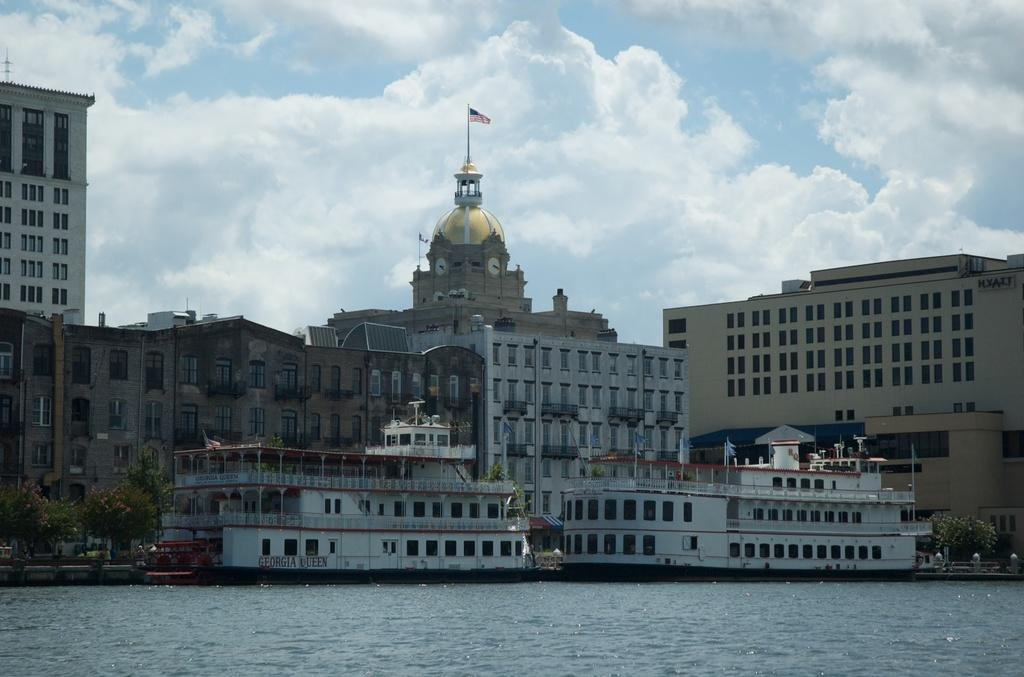What is on the water in the image? There are ships on the water in the image. What else can be seen in the image besides the ships? There are buildings, a flag with a pole, trees, and the sky visible in the background of the image. What is the route of the cough in the image? There is no cough present in the image, so it is not possible to determine a route. What is the relation between the trees and the buildings in the image? The provided facts do not mention any relation between the trees and the buildings; they are simply two separate elements in the image. 